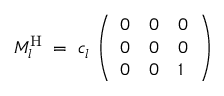Convert formula to latex. <formula><loc_0><loc_0><loc_500><loc_500>M _ { l } ^ { H } \, = \, c _ { l } \left ( \begin{array} { l l l } { 0 } & { 0 } & { 0 } \\ { 0 } & { 0 } & { 0 } \\ { 0 } & { 0 } & { 1 } \end{array} \right ) \,</formula> 